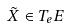<formula> <loc_0><loc_0><loc_500><loc_500>\tilde { X } \in T _ { e } E</formula> 